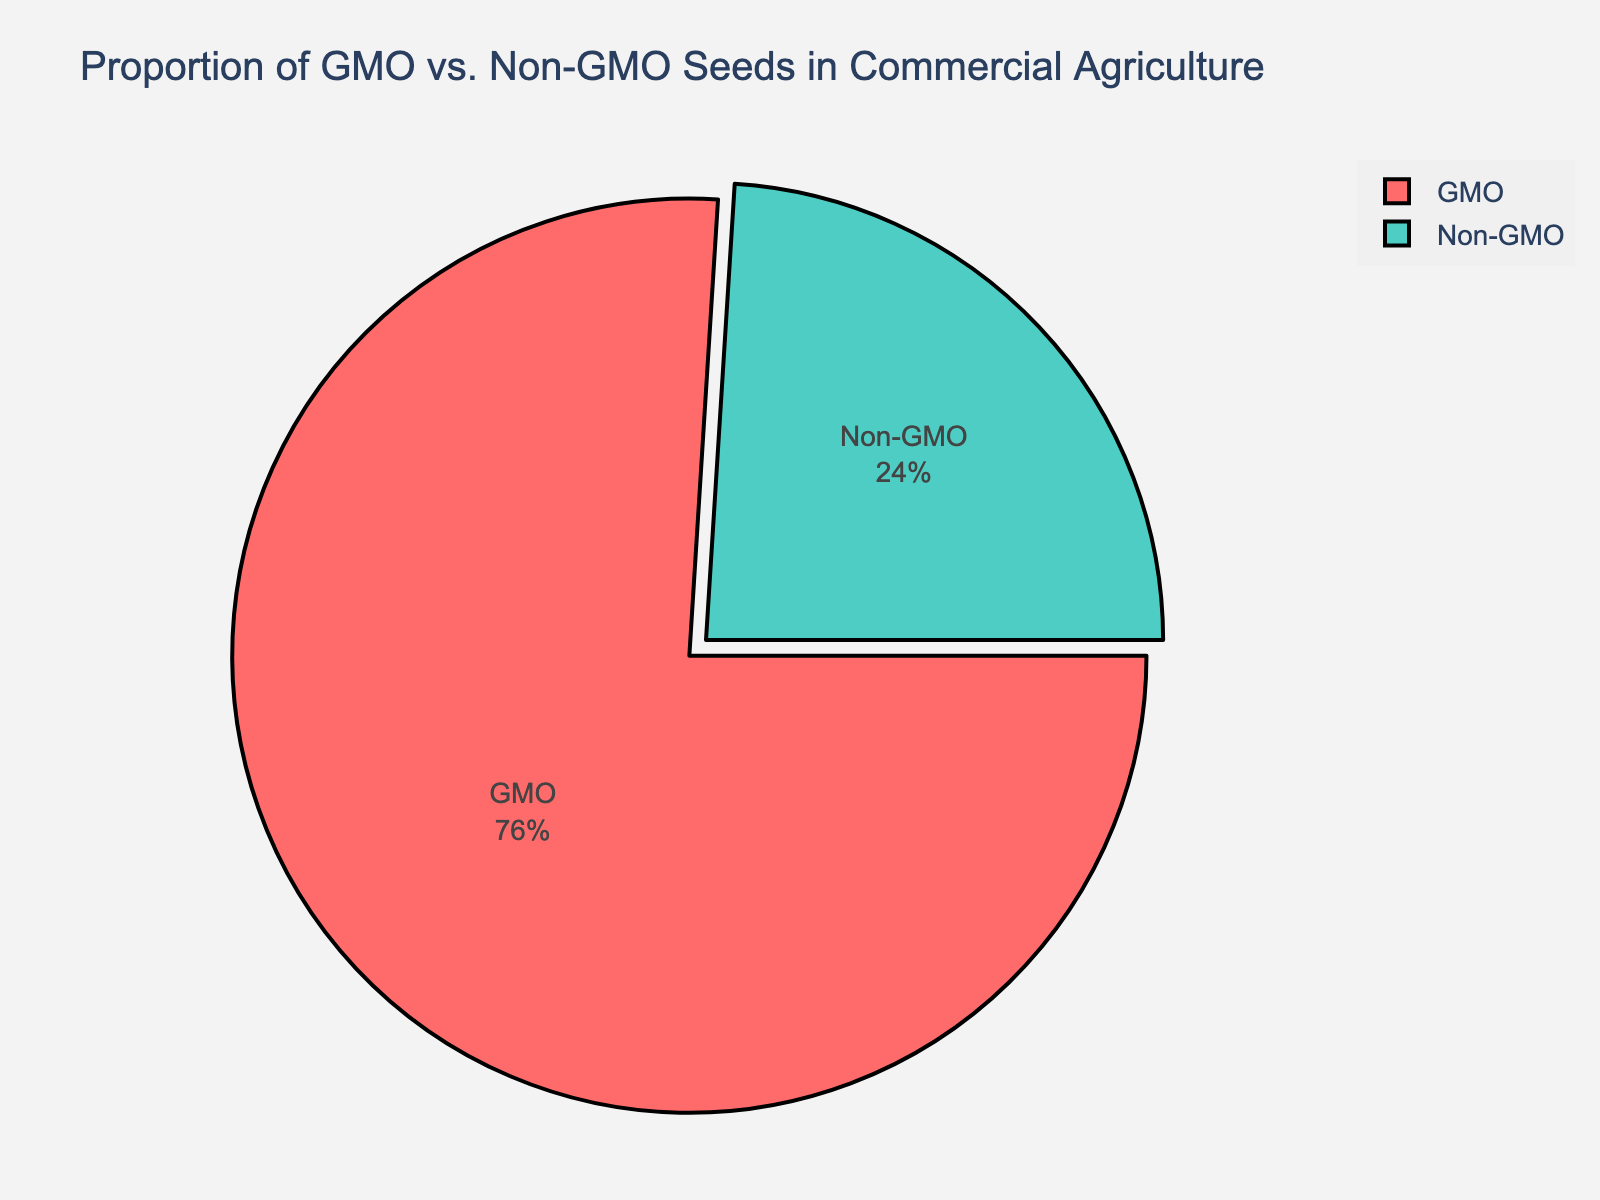Which category has a higher proportion, GMO or non-GMO? The pie chart shows two main categories: GMO and Non-GMO. By looking at the segments, it's clear the GMO segment is significantly larger than the non-GMO segment.
Answer: GMO What is the combined percentage of Genetically Modified Corn and Soybean? Genetically Modified Corn has 33%, and Genetically Modified Soybean has 28%. Summing these two percentages: 33% + 28% = 61%.
Answer: 61% Which has a higher proportion: Genetically Modified Cotton or Non-GMO Heirloom Tomatoes? From the chart, Genetically Modified Cotton is 12%, and Non-GMO Heirloom Tomatoes is 7%. Comparing these, 12% is greater than 7%.
Answer: Genetically Modified Cotton How does the proportion of Non-GMO Organic Wheat compare to Genetically Modified Canola? The pie chart shows 6% for Non-GMO Organic Wheat and 3% for Genetically Modified Canola. Non-GMO Organic Wheat's 6% is double the percentage of Genetically Modified Canola.
Answer: Non-GMO Organic Wheat What is the total percentage of all Genetically Modified seeds combined? The percentages of Genetically Modified seeds are 33% (Corn), 28% (Soybean), 12% (Cotton), and 3% (Canola). Adding these: 33% + 28% + 12% + 3% = 76%.
Answer: 76% Is the proportion of Non-GMO Indigenous Varieties greater than any other type of genetically modified seed? The smallest GMO segment is Genetically Modified Canola at 3%, and Non-GMO Indigenous Varieties has 2%. Hence, 2% is less than 3%.
Answer: No If we exclude Genetically Modified Corn and Soybean, what is the remaining percentage of GMO seeds? Excluding Genetically Modified Corn (33%) and Soybean (28%), we have Genetically Modified Cotton (12%) and Canola (3%) left. Adding these: 12% + 3% = 15%.
Answer: 15% What is the difference in percentage between the largest and smallest GMO seed categories? The largest GMO category is Genetically Modified Corn (33%), and the smallest is Genetically Modified Canola (3%). The difference is: 33% - 3% = 30%.
Answer: 30% 